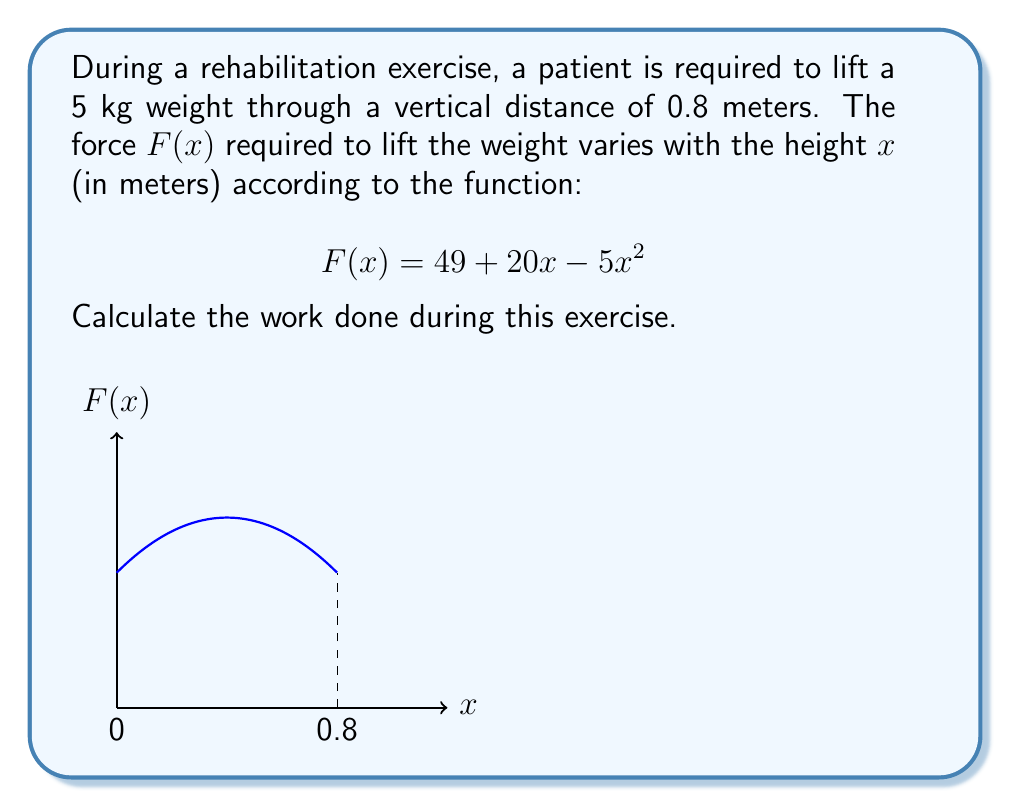Can you answer this question? To solve this problem, we need to use the concept of work as the integral of force over distance. Here's a step-by-step solution:

1) The work done is given by the definite integral of the force function over the distance:

   $$W = \int_0^{0.8} F(x) dx$$

2) Substituting the given force function:

   $$W = \int_0^{0.8} (49 + 20x - 5x^2) dx$$

3) Integrate the function:

   $$W = [49x + 10x^2 - \frac{5}{3}x^3]_0^{0.8}$$

4) Evaluate the integral at the limits:

   $$W = (49(0.8) + 10(0.8)^2 - \frac{5}{3}(0.8)^3) - (49(0) + 10(0)^2 - \frac{5}{3}(0)^3)$$

5) Simplify:

   $$W = (39.2 + 6.4 - 1.365) - 0 = 44.235$$

6) The unit of work is Joules (J), so we add this to our answer.

Therefore, the work done during this rehabilitation exercise is approximately 44.235 J.
Answer: 44.235 J 